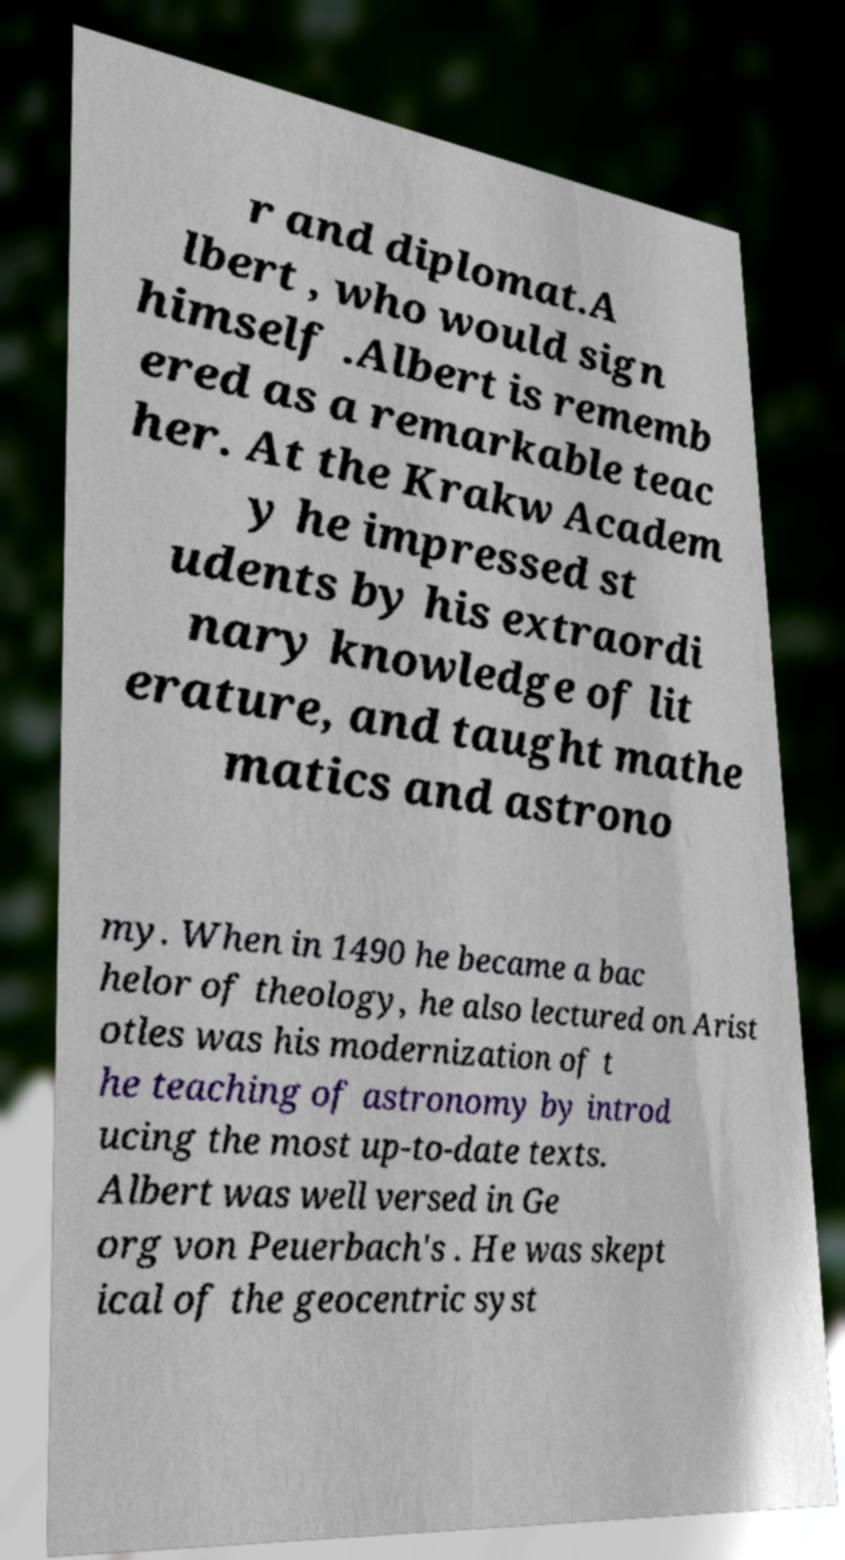There's text embedded in this image that I need extracted. Can you transcribe it verbatim? r and diplomat.A lbert , who would sign himself .Albert is rememb ered as a remarkable teac her. At the Krakw Academ y he impressed st udents by his extraordi nary knowledge of lit erature, and taught mathe matics and astrono my. When in 1490 he became a bac helor of theology, he also lectured on Arist otles was his modernization of t he teaching of astronomy by introd ucing the most up-to-date texts. Albert was well versed in Ge org von Peuerbach's . He was skept ical of the geocentric syst 